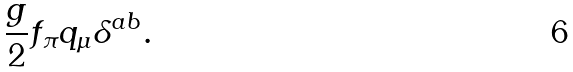<formula> <loc_0><loc_0><loc_500><loc_500>\frac { g } { 2 } f _ { \pi } q _ { \mu } \delta ^ { a b } .</formula> 